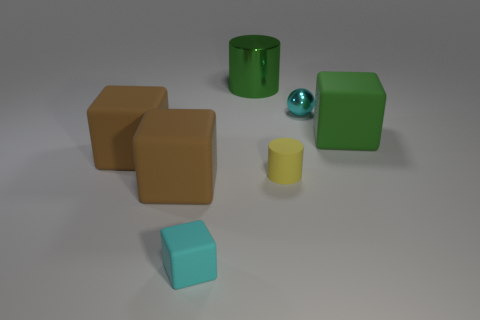Add 2 green matte cubes. How many objects exist? 9 Subtract all small cyan blocks. How many blocks are left? 3 Subtract all green cylinders. How many cylinders are left? 1 Subtract 2 blocks. How many blocks are left? 2 Subtract 1 cyan blocks. How many objects are left? 6 Subtract all blocks. How many objects are left? 3 Subtract all green cubes. Subtract all cyan balls. How many cubes are left? 3 Subtract all yellow cylinders. How many cyan cubes are left? 1 Subtract all small yellow objects. Subtract all big brown matte objects. How many objects are left? 4 Add 1 shiny things. How many shiny things are left? 3 